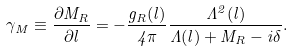Convert formula to latex. <formula><loc_0><loc_0><loc_500><loc_500>\gamma _ { M } \equiv \frac { \partial M _ { R } } { \partial l } = - \frac { g _ { R } ( l ) } { 4 \pi } \frac { \Lambda ^ { 2 } ( l ) } { \Lambda ( l ) + M _ { R } - i \delta } .</formula> 